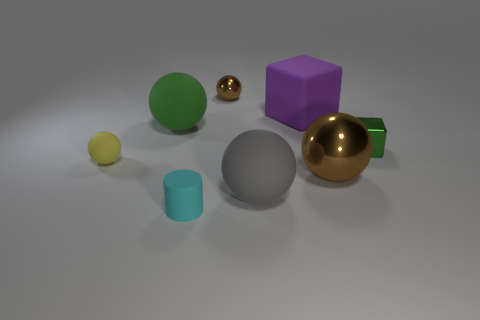Subtract all yellow balls. How many balls are left? 4 Subtract all tiny rubber balls. How many balls are left? 4 Subtract all blue spheres. Subtract all red cylinders. How many spheres are left? 5 Add 2 green matte balls. How many objects exist? 10 Subtract all cubes. How many objects are left? 6 Add 2 cyan cylinders. How many cyan cylinders are left? 3 Add 3 green cubes. How many green cubes exist? 4 Subtract 0 yellow cylinders. How many objects are left? 8 Subtract all big brown matte cubes. Subtract all green cubes. How many objects are left? 7 